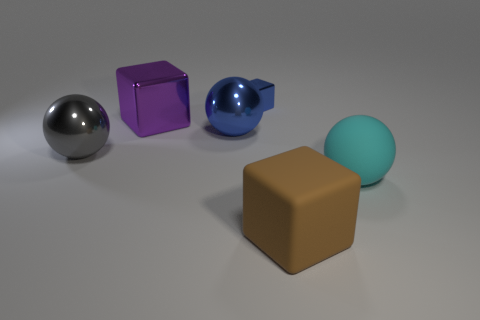What could be the purpose of creating an image like this? An image like this might serve several purposes, such as showcasing 3D modeling skills, testing material rendering, lighting effects, or to serve as a reference for objects in a larger project. It could also simply be a piece of abstract art or part of a visual study in geometry and color. 